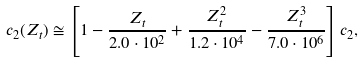Convert formula to latex. <formula><loc_0><loc_0><loc_500><loc_500>c _ { 2 } ( Z _ { t } ) \cong \left [ 1 - \frac { Z _ { t } } { 2 . 0 \cdot 1 0 ^ { 2 } } + \frac { Z _ { t } ^ { 2 } } { 1 . 2 \cdot 1 0 ^ { 4 } } - \frac { Z _ { t } ^ { 3 } } { 7 . 0 \cdot 1 0 ^ { 6 } } \right ] c _ { 2 } ,</formula> 